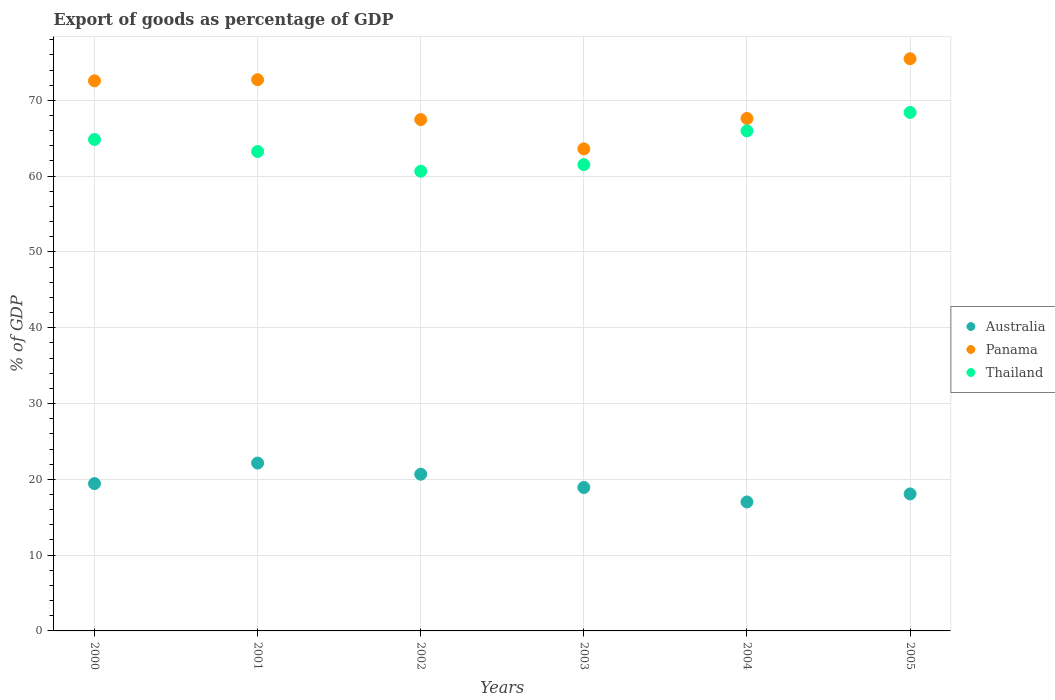How many different coloured dotlines are there?
Make the answer very short. 3. What is the export of goods as percentage of GDP in Panama in 2005?
Your response must be concise. 75.49. Across all years, what is the maximum export of goods as percentage of GDP in Australia?
Offer a terse response. 22.15. Across all years, what is the minimum export of goods as percentage of GDP in Australia?
Your answer should be compact. 17.01. In which year was the export of goods as percentage of GDP in Panama maximum?
Make the answer very short. 2005. What is the total export of goods as percentage of GDP in Thailand in the graph?
Make the answer very short. 384.63. What is the difference between the export of goods as percentage of GDP in Panama in 2001 and that in 2002?
Make the answer very short. 5.26. What is the difference between the export of goods as percentage of GDP in Panama in 2004 and the export of goods as percentage of GDP in Thailand in 2000?
Provide a short and direct response. 2.77. What is the average export of goods as percentage of GDP in Australia per year?
Ensure brevity in your answer.  19.38. In the year 2002, what is the difference between the export of goods as percentage of GDP in Thailand and export of goods as percentage of GDP in Panama?
Offer a terse response. -6.81. In how many years, is the export of goods as percentage of GDP in Panama greater than 30 %?
Your answer should be very brief. 6. What is the ratio of the export of goods as percentage of GDP in Panama in 2001 to that in 2003?
Keep it short and to the point. 1.14. Is the export of goods as percentage of GDP in Panama in 2000 less than that in 2003?
Offer a very short reply. No. Is the difference between the export of goods as percentage of GDP in Thailand in 2002 and 2005 greater than the difference between the export of goods as percentage of GDP in Panama in 2002 and 2005?
Make the answer very short. Yes. What is the difference between the highest and the second highest export of goods as percentage of GDP in Panama?
Provide a short and direct response. 2.77. What is the difference between the highest and the lowest export of goods as percentage of GDP in Australia?
Offer a very short reply. 5.13. How many years are there in the graph?
Your answer should be very brief. 6. What is the difference between two consecutive major ticks on the Y-axis?
Your answer should be compact. 10. Are the values on the major ticks of Y-axis written in scientific E-notation?
Your answer should be compact. No. Does the graph contain grids?
Your answer should be compact. Yes. Where does the legend appear in the graph?
Offer a terse response. Center right. How many legend labels are there?
Your response must be concise. 3. How are the legend labels stacked?
Your answer should be compact. Vertical. What is the title of the graph?
Your answer should be compact. Export of goods as percentage of GDP. Does "Fiji" appear as one of the legend labels in the graph?
Provide a short and direct response. No. What is the label or title of the Y-axis?
Ensure brevity in your answer.  % of GDP. What is the % of GDP of Australia in 2000?
Keep it short and to the point. 19.44. What is the % of GDP of Panama in 2000?
Make the answer very short. 72.58. What is the % of GDP in Thailand in 2000?
Your answer should be compact. 64.84. What is the % of GDP of Australia in 2001?
Your answer should be very brief. 22.15. What is the % of GDP of Panama in 2001?
Offer a very short reply. 72.72. What is the % of GDP in Thailand in 2001?
Offer a very short reply. 63.25. What is the % of GDP of Australia in 2002?
Your answer should be very brief. 20.68. What is the % of GDP in Panama in 2002?
Keep it short and to the point. 67.46. What is the % of GDP in Thailand in 2002?
Your response must be concise. 60.65. What is the % of GDP in Australia in 2003?
Ensure brevity in your answer.  18.92. What is the % of GDP of Panama in 2003?
Give a very brief answer. 63.6. What is the % of GDP in Thailand in 2003?
Give a very brief answer. 61.52. What is the % of GDP in Australia in 2004?
Offer a terse response. 17.01. What is the % of GDP in Panama in 2004?
Your answer should be very brief. 67.61. What is the % of GDP of Thailand in 2004?
Provide a short and direct response. 65.97. What is the % of GDP of Australia in 2005?
Keep it short and to the point. 18.07. What is the % of GDP in Panama in 2005?
Keep it short and to the point. 75.49. What is the % of GDP of Thailand in 2005?
Your response must be concise. 68.4. Across all years, what is the maximum % of GDP in Australia?
Offer a terse response. 22.15. Across all years, what is the maximum % of GDP of Panama?
Provide a succinct answer. 75.49. Across all years, what is the maximum % of GDP of Thailand?
Give a very brief answer. 68.4. Across all years, what is the minimum % of GDP of Australia?
Offer a very short reply. 17.01. Across all years, what is the minimum % of GDP of Panama?
Ensure brevity in your answer.  63.6. Across all years, what is the minimum % of GDP in Thailand?
Your answer should be compact. 60.65. What is the total % of GDP in Australia in the graph?
Provide a succinct answer. 116.27. What is the total % of GDP of Panama in the graph?
Offer a very short reply. 419.45. What is the total % of GDP in Thailand in the graph?
Offer a very short reply. 384.63. What is the difference between the % of GDP in Australia in 2000 and that in 2001?
Offer a terse response. -2.71. What is the difference between the % of GDP in Panama in 2000 and that in 2001?
Ensure brevity in your answer.  -0.15. What is the difference between the % of GDP of Thailand in 2000 and that in 2001?
Your answer should be compact. 1.59. What is the difference between the % of GDP in Australia in 2000 and that in 2002?
Provide a succinct answer. -1.24. What is the difference between the % of GDP of Panama in 2000 and that in 2002?
Keep it short and to the point. 5.12. What is the difference between the % of GDP of Thailand in 2000 and that in 2002?
Offer a terse response. 4.19. What is the difference between the % of GDP in Australia in 2000 and that in 2003?
Ensure brevity in your answer.  0.51. What is the difference between the % of GDP in Panama in 2000 and that in 2003?
Give a very brief answer. 8.98. What is the difference between the % of GDP in Thailand in 2000 and that in 2003?
Provide a short and direct response. 3.32. What is the difference between the % of GDP of Australia in 2000 and that in 2004?
Your answer should be very brief. 2.42. What is the difference between the % of GDP of Panama in 2000 and that in 2004?
Your answer should be compact. 4.97. What is the difference between the % of GDP of Thailand in 2000 and that in 2004?
Your answer should be compact. -1.13. What is the difference between the % of GDP of Australia in 2000 and that in 2005?
Your answer should be very brief. 1.36. What is the difference between the % of GDP in Panama in 2000 and that in 2005?
Offer a terse response. -2.91. What is the difference between the % of GDP of Thailand in 2000 and that in 2005?
Ensure brevity in your answer.  -3.56. What is the difference between the % of GDP in Australia in 2001 and that in 2002?
Ensure brevity in your answer.  1.47. What is the difference between the % of GDP in Panama in 2001 and that in 2002?
Your answer should be very brief. 5.26. What is the difference between the % of GDP in Thailand in 2001 and that in 2002?
Your response must be concise. 2.6. What is the difference between the % of GDP of Australia in 2001 and that in 2003?
Your answer should be very brief. 3.22. What is the difference between the % of GDP of Panama in 2001 and that in 2003?
Provide a succinct answer. 9.12. What is the difference between the % of GDP in Thailand in 2001 and that in 2003?
Your response must be concise. 1.73. What is the difference between the % of GDP in Australia in 2001 and that in 2004?
Your response must be concise. 5.13. What is the difference between the % of GDP in Panama in 2001 and that in 2004?
Ensure brevity in your answer.  5.11. What is the difference between the % of GDP in Thailand in 2001 and that in 2004?
Provide a succinct answer. -2.72. What is the difference between the % of GDP in Australia in 2001 and that in 2005?
Ensure brevity in your answer.  4.07. What is the difference between the % of GDP of Panama in 2001 and that in 2005?
Provide a succinct answer. -2.77. What is the difference between the % of GDP in Thailand in 2001 and that in 2005?
Keep it short and to the point. -5.15. What is the difference between the % of GDP of Australia in 2002 and that in 2003?
Provide a short and direct response. 1.75. What is the difference between the % of GDP of Panama in 2002 and that in 2003?
Give a very brief answer. 3.86. What is the difference between the % of GDP of Thailand in 2002 and that in 2003?
Provide a short and direct response. -0.88. What is the difference between the % of GDP in Australia in 2002 and that in 2004?
Your response must be concise. 3.66. What is the difference between the % of GDP in Panama in 2002 and that in 2004?
Your answer should be compact. -0.15. What is the difference between the % of GDP of Thailand in 2002 and that in 2004?
Provide a succinct answer. -5.33. What is the difference between the % of GDP of Australia in 2002 and that in 2005?
Provide a succinct answer. 2.6. What is the difference between the % of GDP of Panama in 2002 and that in 2005?
Offer a terse response. -8.03. What is the difference between the % of GDP in Thailand in 2002 and that in 2005?
Your response must be concise. -7.76. What is the difference between the % of GDP in Australia in 2003 and that in 2004?
Offer a terse response. 1.91. What is the difference between the % of GDP of Panama in 2003 and that in 2004?
Offer a terse response. -4.01. What is the difference between the % of GDP of Thailand in 2003 and that in 2004?
Keep it short and to the point. -4.45. What is the difference between the % of GDP of Australia in 2003 and that in 2005?
Offer a terse response. 0.85. What is the difference between the % of GDP of Panama in 2003 and that in 2005?
Provide a succinct answer. -11.89. What is the difference between the % of GDP in Thailand in 2003 and that in 2005?
Your response must be concise. -6.88. What is the difference between the % of GDP of Australia in 2004 and that in 2005?
Your response must be concise. -1.06. What is the difference between the % of GDP in Panama in 2004 and that in 2005?
Your answer should be very brief. -7.88. What is the difference between the % of GDP in Thailand in 2004 and that in 2005?
Ensure brevity in your answer.  -2.43. What is the difference between the % of GDP in Australia in 2000 and the % of GDP in Panama in 2001?
Make the answer very short. -53.28. What is the difference between the % of GDP in Australia in 2000 and the % of GDP in Thailand in 2001?
Make the answer very short. -43.81. What is the difference between the % of GDP in Panama in 2000 and the % of GDP in Thailand in 2001?
Provide a short and direct response. 9.32. What is the difference between the % of GDP in Australia in 2000 and the % of GDP in Panama in 2002?
Your answer should be very brief. -48.02. What is the difference between the % of GDP in Australia in 2000 and the % of GDP in Thailand in 2002?
Offer a very short reply. -41.21. What is the difference between the % of GDP in Panama in 2000 and the % of GDP in Thailand in 2002?
Your answer should be compact. 11.93. What is the difference between the % of GDP in Australia in 2000 and the % of GDP in Panama in 2003?
Provide a short and direct response. -44.16. What is the difference between the % of GDP of Australia in 2000 and the % of GDP of Thailand in 2003?
Provide a short and direct response. -42.09. What is the difference between the % of GDP in Panama in 2000 and the % of GDP in Thailand in 2003?
Your response must be concise. 11.05. What is the difference between the % of GDP in Australia in 2000 and the % of GDP in Panama in 2004?
Offer a terse response. -48.17. What is the difference between the % of GDP of Australia in 2000 and the % of GDP of Thailand in 2004?
Provide a succinct answer. -46.54. What is the difference between the % of GDP of Panama in 2000 and the % of GDP of Thailand in 2004?
Offer a very short reply. 6.6. What is the difference between the % of GDP of Australia in 2000 and the % of GDP of Panama in 2005?
Your answer should be very brief. -56.05. What is the difference between the % of GDP in Australia in 2000 and the % of GDP in Thailand in 2005?
Keep it short and to the point. -48.97. What is the difference between the % of GDP of Panama in 2000 and the % of GDP of Thailand in 2005?
Ensure brevity in your answer.  4.17. What is the difference between the % of GDP of Australia in 2001 and the % of GDP of Panama in 2002?
Offer a terse response. -45.31. What is the difference between the % of GDP in Australia in 2001 and the % of GDP in Thailand in 2002?
Your answer should be compact. -38.5. What is the difference between the % of GDP of Panama in 2001 and the % of GDP of Thailand in 2002?
Provide a short and direct response. 12.07. What is the difference between the % of GDP in Australia in 2001 and the % of GDP in Panama in 2003?
Your answer should be compact. -41.45. What is the difference between the % of GDP of Australia in 2001 and the % of GDP of Thailand in 2003?
Offer a very short reply. -39.38. What is the difference between the % of GDP of Panama in 2001 and the % of GDP of Thailand in 2003?
Your answer should be very brief. 11.2. What is the difference between the % of GDP of Australia in 2001 and the % of GDP of Panama in 2004?
Give a very brief answer. -45.46. What is the difference between the % of GDP of Australia in 2001 and the % of GDP of Thailand in 2004?
Your response must be concise. -43.82. What is the difference between the % of GDP of Panama in 2001 and the % of GDP of Thailand in 2004?
Ensure brevity in your answer.  6.75. What is the difference between the % of GDP in Australia in 2001 and the % of GDP in Panama in 2005?
Your answer should be compact. -53.34. What is the difference between the % of GDP of Australia in 2001 and the % of GDP of Thailand in 2005?
Provide a short and direct response. -46.26. What is the difference between the % of GDP of Panama in 2001 and the % of GDP of Thailand in 2005?
Provide a short and direct response. 4.32. What is the difference between the % of GDP of Australia in 2002 and the % of GDP of Panama in 2003?
Ensure brevity in your answer.  -42.92. What is the difference between the % of GDP in Australia in 2002 and the % of GDP in Thailand in 2003?
Provide a succinct answer. -40.85. What is the difference between the % of GDP of Panama in 2002 and the % of GDP of Thailand in 2003?
Provide a short and direct response. 5.94. What is the difference between the % of GDP of Australia in 2002 and the % of GDP of Panama in 2004?
Your response must be concise. -46.93. What is the difference between the % of GDP of Australia in 2002 and the % of GDP of Thailand in 2004?
Keep it short and to the point. -45.3. What is the difference between the % of GDP of Panama in 2002 and the % of GDP of Thailand in 2004?
Your response must be concise. 1.49. What is the difference between the % of GDP in Australia in 2002 and the % of GDP in Panama in 2005?
Offer a terse response. -54.81. What is the difference between the % of GDP of Australia in 2002 and the % of GDP of Thailand in 2005?
Offer a terse response. -47.73. What is the difference between the % of GDP of Panama in 2002 and the % of GDP of Thailand in 2005?
Make the answer very short. -0.94. What is the difference between the % of GDP of Australia in 2003 and the % of GDP of Panama in 2004?
Your answer should be compact. -48.69. What is the difference between the % of GDP in Australia in 2003 and the % of GDP in Thailand in 2004?
Make the answer very short. -47.05. What is the difference between the % of GDP of Panama in 2003 and the % of GDP of Thailand in 2004?
Offer a terse response. -2.37. What is the difference between the % of GDP of Australia in 2003 and the % of GDP of Panama in 2005?
Your answer should be compact. -56.57. What is the difference between the % of GDP of Australia in 2003 and the % of GDP of Thailand in 2005?
Offer a very short reply. -49.48. What is the difference between the % of GDP in Panama in 2003 and the % of GDP in Thailand in 2005?
Offer a terse response. -4.81. What is the difference between the % of GDP of Australia in 2004 and the % of GDP of Panama in 2005?
Provide a succinct answer. -58.48. What is the difference between the % of GDP of Australia in 2004 and the % of GDP of Thailand in 2005?
Provide a short and direct response. -51.39. What is the difference between the % of GDP in Panama in 2004 and the % of GDP in Thailand in 2005?
Make the answer very short. -0.79. What is the average % of GDP of Australia per year?
Make the answer very short. 19.38. What is the average % of GDP of Panama per year?
Keep it short and to the point. 69.91. What is the average % of GDP of Thailand per year?
Your response must be concise. 64.11. In the year 2000, what is the difference between the % of GDP in Australia and % of GDP in Panama?
Ensure brevity in your answer.  -53.14. In the year 2000, what is the difference between the % of GDP in Australia and % of GDP in Thailand?
Provide a short and direct response. -45.4. In the year 2000, what is the difference between the % of GDP of Panama and % of GDP of Thailand?
Keep it short and to the point. 7.74. In the year 2001, what is the difference between the % of GDP in Australia and % of GDP in Panama?
Your response must be concise. -50.57. In the year 2001, what is the difference between the % of GDP of Australia and % of GDP of Thailand?
Provide a succinct answer. -41.1. In the year 2001, what is the difference between the % of GDP in Panama and % of GDP in Thailand?
Make the answer very short. 9.47. In the year 2002, what is the difference between the % of GDP in Australia and % of GDP in Panama?
Your response must be concise. -46.78. In the year 2002, what is the difference between the % of GDP of Australia and % of GDP of Thailand?
Keep it short and to the point. -39.97. In the year 2002, what is the difference between the % of GDP in Panama and % of GDP in Thailand?
Provide a succinct answer. 6.81. In the year 2003, what is the difference between the % of GDP of Australia and % of GDP of Panama?
Provide a short and direct response. -44.68. In the year 2003, what is the difference between the % of GDP of Australia and % of GDP of Thailand?
Your answer should be compact. -42.6. In the year 2003, what is the difference between the % of GDP in Panama and % of GDP in Thailand?
Ensure brevity in your answer.  2.08. In the year 2004, what is the difference between the % of GDP of Australia and % of GDP of Panama?
Your answer should be compact. -50.6. In the year 2004, what is the difference between the % of GDP in Australia and % of GDP in Thailand?
Make the answer very short. -48.96. In the year 2004, what is the difference between the % of GDP in Panama and % of GDP in Thailand?
Provide a succinct answer. 1.64. In the year 2005, what is the difference between the % of GDP in Australia and % of GDP in Panama?
Provide a short and direct response. -57.41. In the year 2005, what is the difference between the % of GDP of Australia and % of GDP of Thailand?
Provide a short and direct response. -50.33. In the year 2005, what is the difference between the % of GDP in Panama and % of GDP in Thailand?
Give a very brief answer. 7.09. What is the ratio of the % of GDP of Australia in 2000 to that in 2001?
Offer a terse response. 0.88. What is the ratio of the % of GDP in Panama in 2000 to that in 2001?
Provide a short and direct response. 1. What is the ratio of the % of GDP of Thailand in 2000 to that in 2001?
Ensure brevity in your answer.  1.03. What is the ratio of the % of GDP in Australia in 2000 to that in 2002?
Your response must be concise. 0.94. What is the ratio of the % of GDP in Panama in 2000 to that in 2002?
Make the answer very short. 1.08. What is the ratio of the % of GDP in Thailand in 2000 to that in 2002?
Ensure brevity in your answer.  1.07. What is the ratio of the % of GDP in Australia in 2000 to that in 2003?
Give a very brief answer. 1.03. What is the ratio of the % of GDP of Panama in 2000 to that in 2003?
Give a very brief answer. 1.14. What is the ratio of the % of GDP in Thailand in 2000 to that in 2003?
Make the answer very short. 1.05. What is the ratio of the % of GDP of Australia in 2000 to that in 2004?
Your response must be concise. 1.14. What is the ratio of the % of GDP of Panama in 2000 to that in 2004?
Give a very brief answer. 1.07. What is the ratio of the % of GDP in Thailand in 2000 to that in 2004?
Keep it short and to the point. 0.98. What is the ratio of the % of GDP in Australia in 2000 to that in 2005?
Offer a terse response. 1.08. What is the ratio of the % of GDP of Panama in 2000 to that in 2005?
Provide a succinct answer. 0.96. What is the ratio of the % of GDP in Thailand in 2000 to that in 2005?
Offer a terse response. 0.95. What is the ratio of the % of GDP in Australia in 2001 to that in 2002?
Provide a short and direct response. 1.07. What is the ratio of the % of GDP of Panama in 2001 to that in 2002?
Ensure brevity in your answer.  1.08. What is the ratio of the % of GDP of Thailand in 2001 to that in 2002?
Provide a succinct answer. 1.04. What is the ratio of the % of GDP in Australia in 2001 to that in 2003?
Keep it short and to the point. 1.17. What is the ratio of the % of GDP of Panama in 2001 to that in 2003?
Give a very brief answer. 1.14. What is the ratio of the % of GDP in Thailand in 2001 to that in 2003?
Your response must be concise. 1.03. What is the ratio of the % of GDP of Australia in 2001 to that in 2004?
Provide a short and direct response. 1.3. What is the ratio of the % of GDP of Panama in 2001 to that in 2004?
Provide a succinct answer. 1.08. What is the ratio of the % of GDP in Thailand in 2001 to that in 2004?
Provide a short and direct response. 0.96. What is the ratio of the % of GDP of Australia in 2001 to that in 2005?
Your answer should be very brief. 1.23. What is the ratio of the % of GDP of Panama in 2001 to that in 2005?
Provide a succinct answer. 0.96. What is the ratio of the % of GDP in Thailand in 2001 to that in 2005?
Your response must be concise. 0.92. What is the ratio of the % of GDP in Australia in 2002 to that in 2003?
Provide a succinct answer. 1.09. What is the ratio of the % of GDP of Panama in 2002 to that in 2003?
Provide a short and direct response. 1.06. What is the ratio of the % of GDP in Thailand in 2002 to that in 2003?
Ensure brevity in your answer.  0.99. What is the ratio of the % of GDP of Australia in 2002 to that in 2004?
Offer a terse response. 1.22. What is the ratio of the % of GDP in Thailand in 2002 to that in 2004?
Keep it short and to the point. 0.92. What is the ratio of the % of GDP in Australia in 2002 to that in 2005?
Give a very brief answer. 1.14. What is the ratio of the % of GDP in Panama in 2002 to that in 2005?
Keep it short and to the point. 0.89. What is the ratio of the % of GDP of Thailand in 2002 to that in 2005?
Provide a short and direct response. 0.89. What is the ratio of the % of GDP in Australia in 2003 to that in 2004?
Offer a very short reply. 1.11. What is the ratio of the % of GDP of Panama in 2003 to that in 2004?
Your answer should be compact. 0.94. What is the ratio of the % of GDP of Thailand in 2003 to that in 2004?
Make the answer very short. 0.93. What is the ratio of the % of GDP of Australia in 2003 to that in 2005?
Keep it short and to the point. 1.05. What is the ratio of the % of GDP in Panama in 2003 to that in 2005?
Keep it short and to the point. 0.84. What is the ratio of the % of GDP of Thailand in 2003 to that in 2005?
Your answer should be very brief. 0.9. What is the ratio of the % of GDP in Australia in 2004 to that in 2005?
Your answer should be compact. 0.94. What is the ratio of the % of GDP of Panama in 2004 to that in 2005?
Your answer should be very brief. 0.9. What is the ratio of the % of GDP of Thailand in 2004 to that in 2005?
Offer a terse response. 0.96. What is the difference between the highest and the second highest % of GDP in Australia?
Your answer should be very brief. 1.47. What is the difference between the highest and the second highest % of GDP of Panama?
Your answer should be very brief. 2.77. What is the difference between the highest and the second highest % of GDP in Thailand?
Ensure brevity in your answer.  2.43. What is the difference between the highest and the lowest % of GDP in Australia?
Offer a terse response. 5.13. What is the difference between the highest and the lowest % of GDP in Panama?
Your response must be concise. 11.89. What is the difference between the highest and the lowest % of GDP of Thailand?
Make the answer very short. 7.76. 